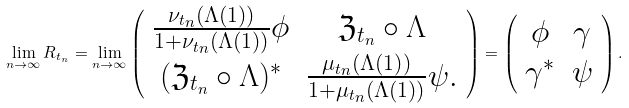Convert formula to latex. <formula><loc_0><loc_0><loc_500><loc_500>\lim _ { n \rightarrow \infty } R _ { t _ { n } } = \lim _ { n \rightarrow \infty } \left ( \begin{array} { c c } \frac { \nu _ { t _ { n } } ( \Lambda ( 1 ) ) } { 1 + \nu _ { t _ { n } } ( \Lambda ( 1 ) ) } \phi & \mathfrak { Z } _ { t _ { n } } \circ \Lambda \\ ( \mathfrak { Z } _ { t _ { n } } \circ \Lambda ) ^ { * } & \frac { \mu _ { t _ { n } } ( \Lambda ( 1 ) ) } { 1 + \mu _ { t _ { n } } ( \Lambda ( 1 ) ) } \psi . \end{array} \right ) = \left ( \begin{array} { c c } \phi & \gamma \\ \gamma ^ { * } & \psi \end{array} \right ) .</formula> 